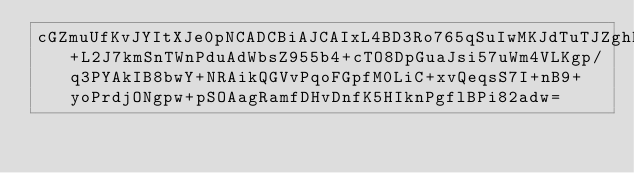Convert code to text. <code><loc_0><loc_0><loc_500><loc_500><_SML_>cGZmuUfKvJYItXJe0pNCADCBiAJCAIxL4BD3Ro765qSuIwMKJdTuTJZghDjX8+L2J7kmSnTWnPduAdWbsZ955b4+cTO8DpGuaJsi57uWm4VLKgp/q3PYAkIB8bwY+NRAikQGVvPqoFGpfM0LiC+xvQeqsS7I+nB9+yoPrdjONgpw+pSOAagRamfDHvDnfK5HIknPgflBPi82adw=</code> 